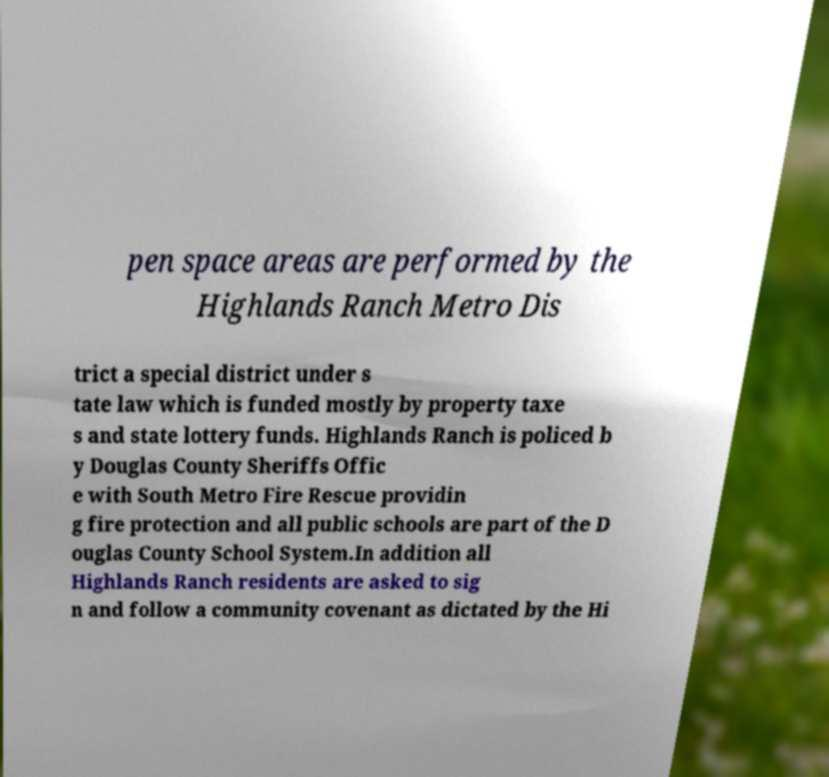Please identify and transcribe the text found in this image. pen space areas are performed by the Highlands Ranch Metro Dis trict a special district under s tate law which is funded mostly by property taxe s and state lottery funds. Highlands Ranch is policed b y Douglas County Sheriffs Offic e with South Metro Fire Rescue providin g fire protection and all public schools are part of the D ouglas County School System.In addition all Highlands Ranch residents are asked to sig n and follow a community covenant as dictated by the Hi 